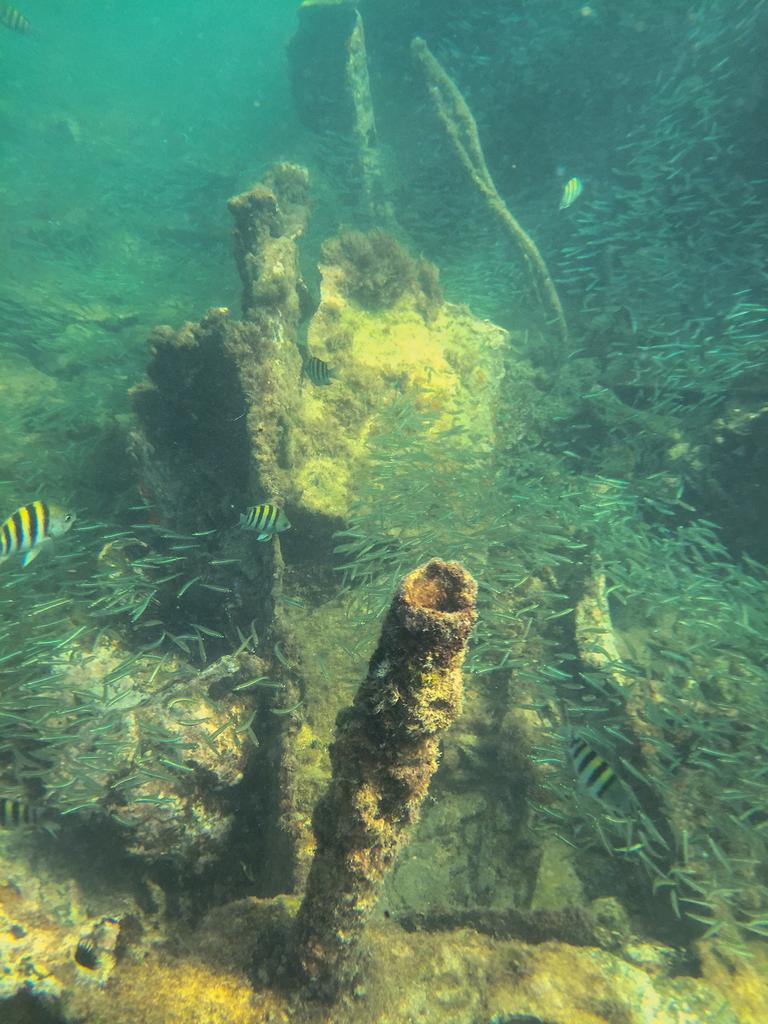Where was the image taken? The image was taken underwater. What types of aquatic animals can be seen in the image? There are many fishes and marine creatures in the image. What type of flag is visible in the image? There is no flag present in the image, as it was taken underwater. What letters can be seen on the marine creatures in the image? There are no letters on the marine creatures in the image; they are natural living organisms. 